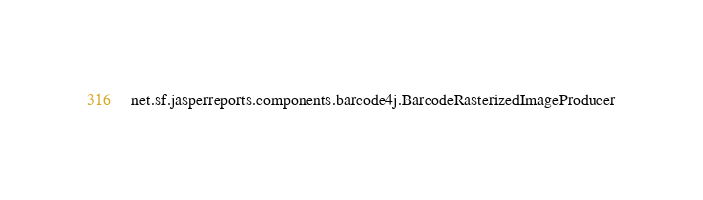<code> <loc_0><loc_0><loc_500><loc_500><_Rust_>net.sf.jasperreports.components.barcode4j.BarcodeRasterizedImageProducer
</code> 